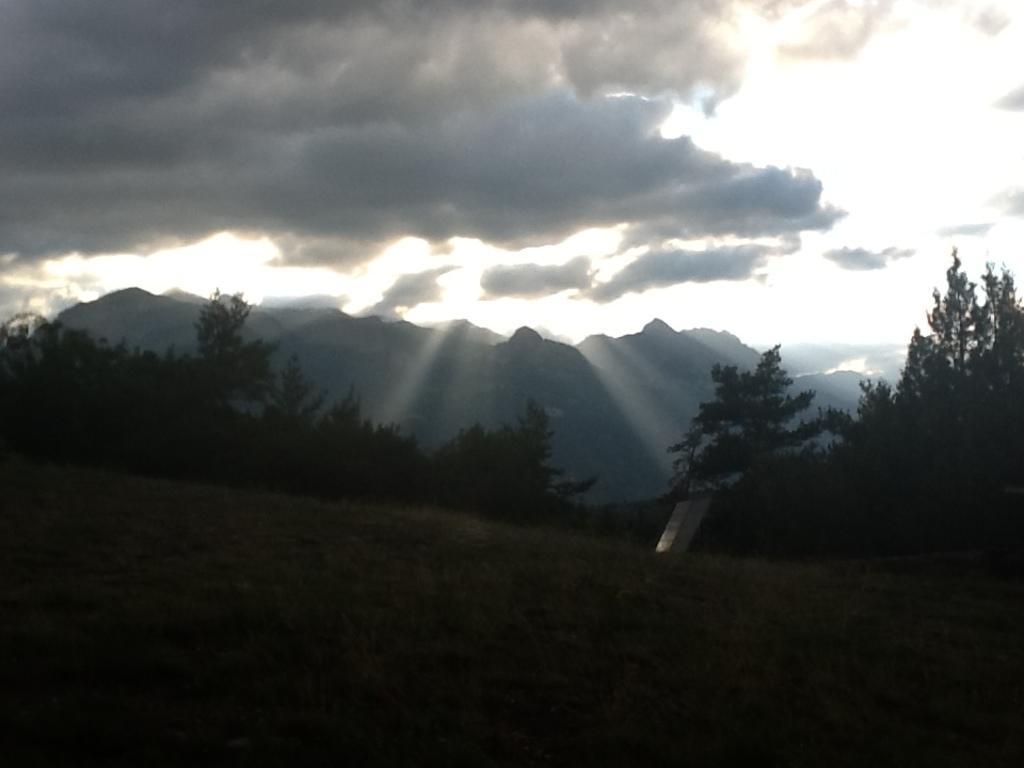Describe this image in one or two sentences. In this image I can see trees, mountains and the sky. This image is little bit dark. 